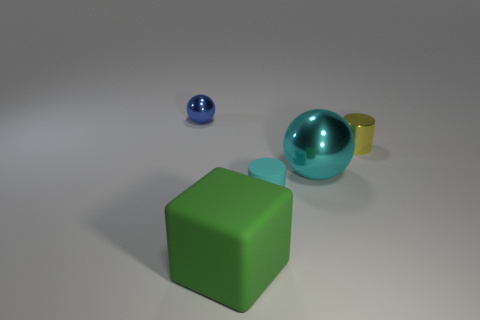How many metal cylinders are behind the small metallic object to the left of the small rubber object?
Offer a very short reply. 0. Are there any yellow shiny cylinders in front of the large cyan metal ball?
Provide a succinct answer. No. Does the matte thing that is to the right of the green matte thing have the same shape as the tiny yellow object?
Make the answer very short. Yes. There is a cylinder that is the same color as the big shiny object; what is it made of?
Offer a very short reply. Rubber. What number of other large metal things are the same color as the large metallic thing?
Provide a short and direct response. 0. What shape is the tiny shiny thing behind the tiny metallic thing to the right of the tiny blue metallic sphere?
Keep it short and to the point. Sphere. Are there any cyan metallic things that have the same shape as the tiny yellow thing?
Your response must be concise. No. There is a small matte cylinder; is it the same color as the thing that is left of the green block?
Offer a very short reply. No. There is a rubber object that is the same color as the big ball; what size is it?
Provide a succinct answer. Small. Is there a green rubber cube of the same size as the green matte thing?
Offer a terse response. No. 